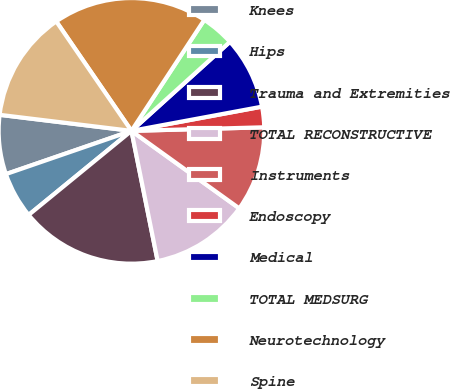<chart> <loc_0><loc_0><loc_500><loc_500><pie_chart><fcel>Knees<fcel>Hips<fcel>Trauma and Extremities<fcel>TOTAL RECONSTRUCTIVE<fcel>Instruments<fcel>Endoscopy<fcel>Medical<fcel>TOTAL MEDSURG<fcel>Neurotechnology<fcel>Spine<nl><fcel>7.21%<fcel>5.63%<fcel>17.25%<fcel>11.92%<fcel>10.35%<fcel>2.49%<fcel>8.78%<fcel>4.06%<fcel>18.82%<fcel>13.49%<nl></chart> 